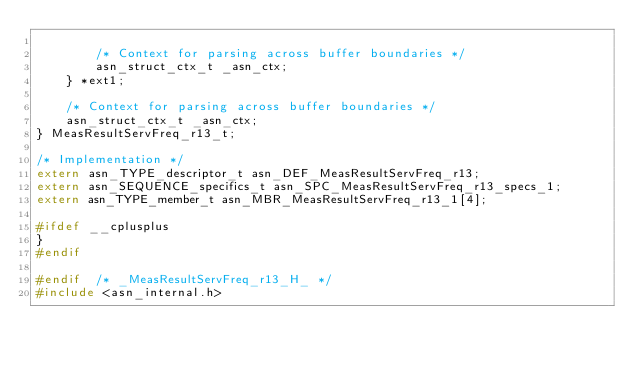Convert code to text. <code><loc_0><loc_0><loc_500><loc_500><_C_>		
		/* Context for parsing across buffer boundaries */
		asn_struct_ctx_t _asn_ctx;
	} *ext1;
	
	/* Context for parsing across buffer boundaries */
	asn_struct_ctx_t _asn_ctx;
} MeasResultServFreq_r13_t;

/* Implementation */
extern asn_TYPE_descriptor_t asn_DEF_MeasResultServFreq_r13;
extern asn_SEQUENCE_specifics_t asn_SPC_MeasResultServFreq_r13_specs_1;
extern asn_TYPE_member_t asn_MBR_MeasResultServFreq_r13_1[4];

#ifdef __cplusplus
}
#endif

#endif	/* _MeasResultServFreq_r13_H_ */
#include <asn_internal.h>
</code> 